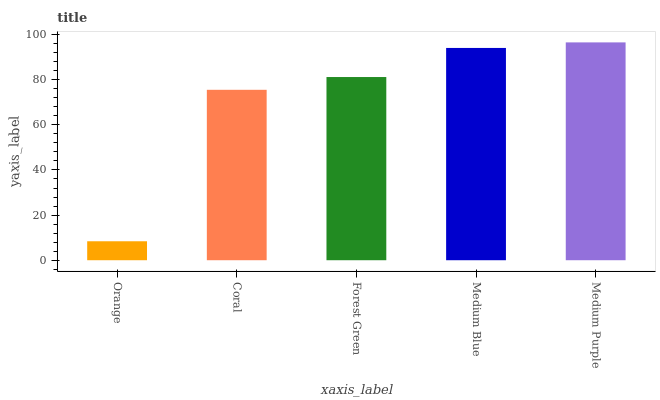Is Orange the minimum?
Answer yes or no. Yes. Is Medium Purple the maximum?
Answer yes or no. Yes. Is Coral the minimum?
Answer yes or no. No. Is Coral the maximum?
Answer yes or no. No. Is Coral greater than Orange?
Answer yes or no. Yes. Is Orange less than Coral?
Answer yes or no. Yes. Is Orange greater than Coral?
Answer yes or no. No. Is Coral less than Orange?
Answer yes or no. No. Is Forest Green the high median?
Answer yes or no. Yes. Is Forest Green the low median?
Answer yes or no. Yes. Is Coral the high median?
Answer yes or no. No. Is Orange the low median?
Answer yes or no. No. 